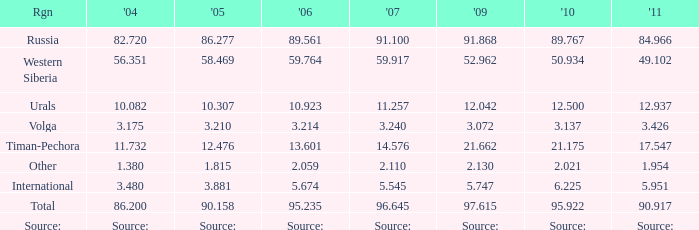What is the 2004 Lukoil oil prodroduction when in 2011 oil production 90.917 million tonnes? 86.2. 